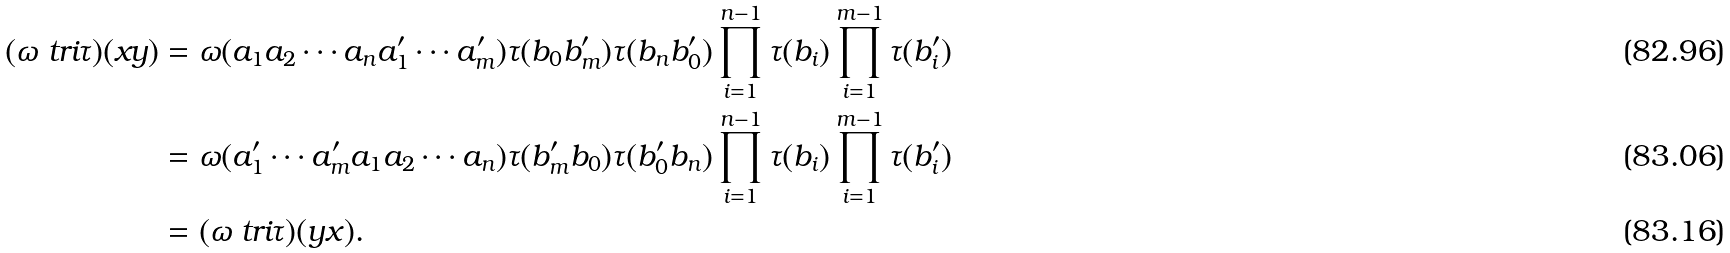<formula> <loc_0><loc_0><loc_500><loc_500>( \omega \ t r i \tau ) ( x y ) & = \omega ( a _ { 1 } a _ { 2 } \cdots a _ { n } a _ { 1 } ^ { \prime } \cdots a _ { m } ^ { \prime } ) \tau ( b _ { 0 } b _ { m } ^ { \prime } ) \tau ( b _ { n } b _ { 0 } ^ { \prime } ) \prod _ { i = 1 } ^ { n - 1 } \tau ( b _ { i } ) \prod _ { i = 1 } ^ { m - 1 } \tau ( b _ { i } ^ { \prime } ) \\ & = \omega ( a _ { 1 } ^ { \prime } \cdots a _ { m } ^ { \prime } a _ { 1 } a _ { 2 } \cdots a _ { n } ) \tau ( b _ { m } ^ { \prime } b _ { 0 } ) \tau ( b _ { 0 } ^ { \prime } b _ { n } ) \prod _ { i = 1 } ^ { n - 1 } \tau ( b _ { i } ) \prod _ { i = 1 } ^ { m - 1 } \tau ( b _ { i } ^ { \prime } ) \\ & = ( \omega \ t r i \tau ) ( y x ) .</formula> 